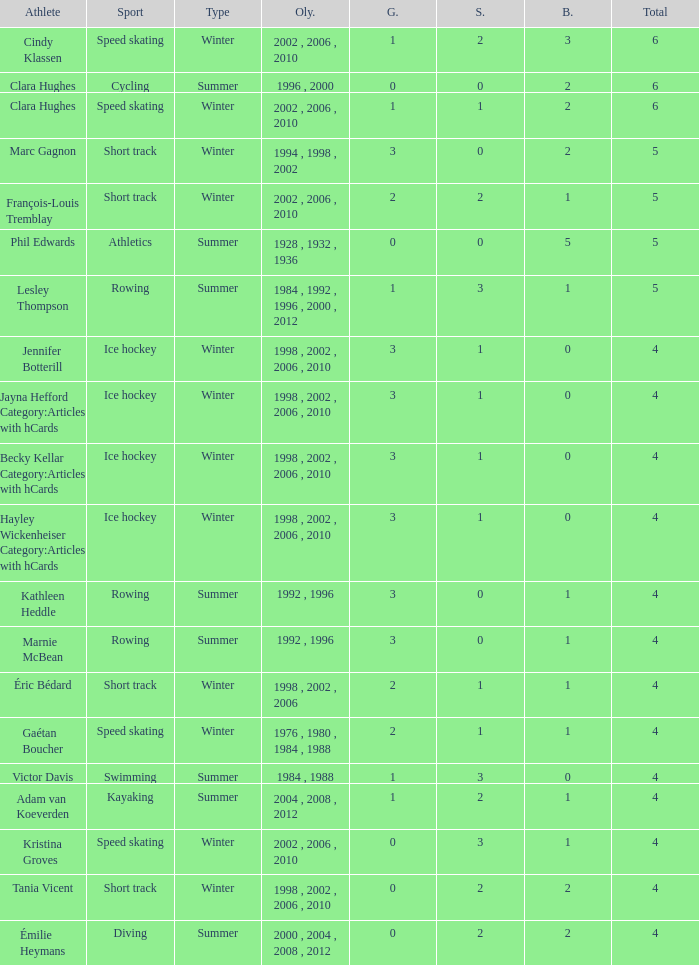What is the highest total medals winter athlete Clara Hughes has? 6.0. 